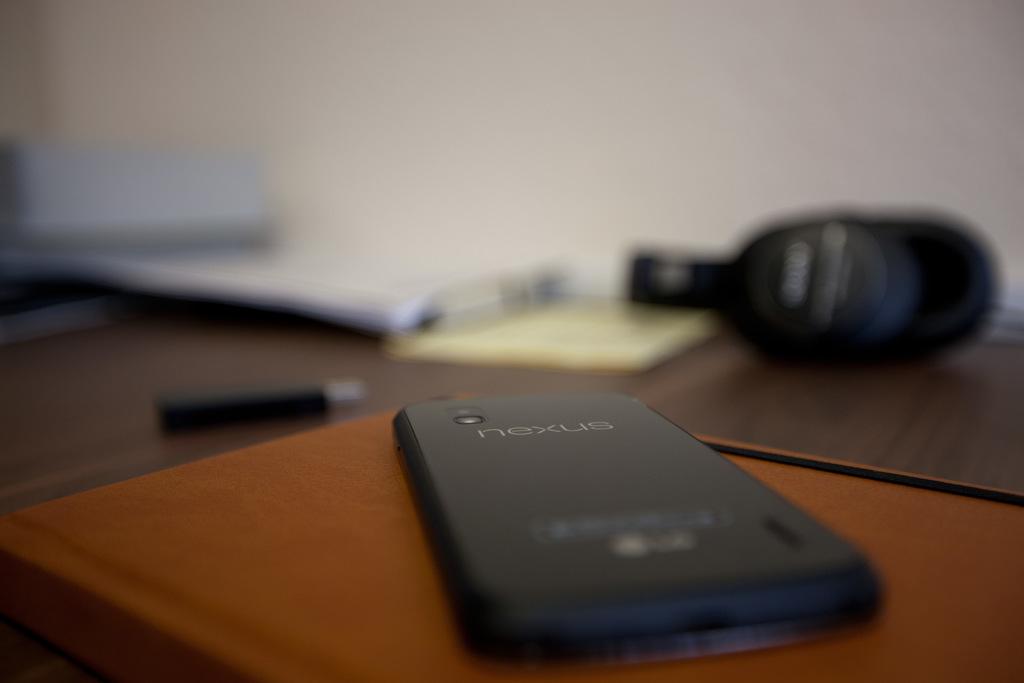What brand phone is this?
Your answer should be compact. Nexus. 